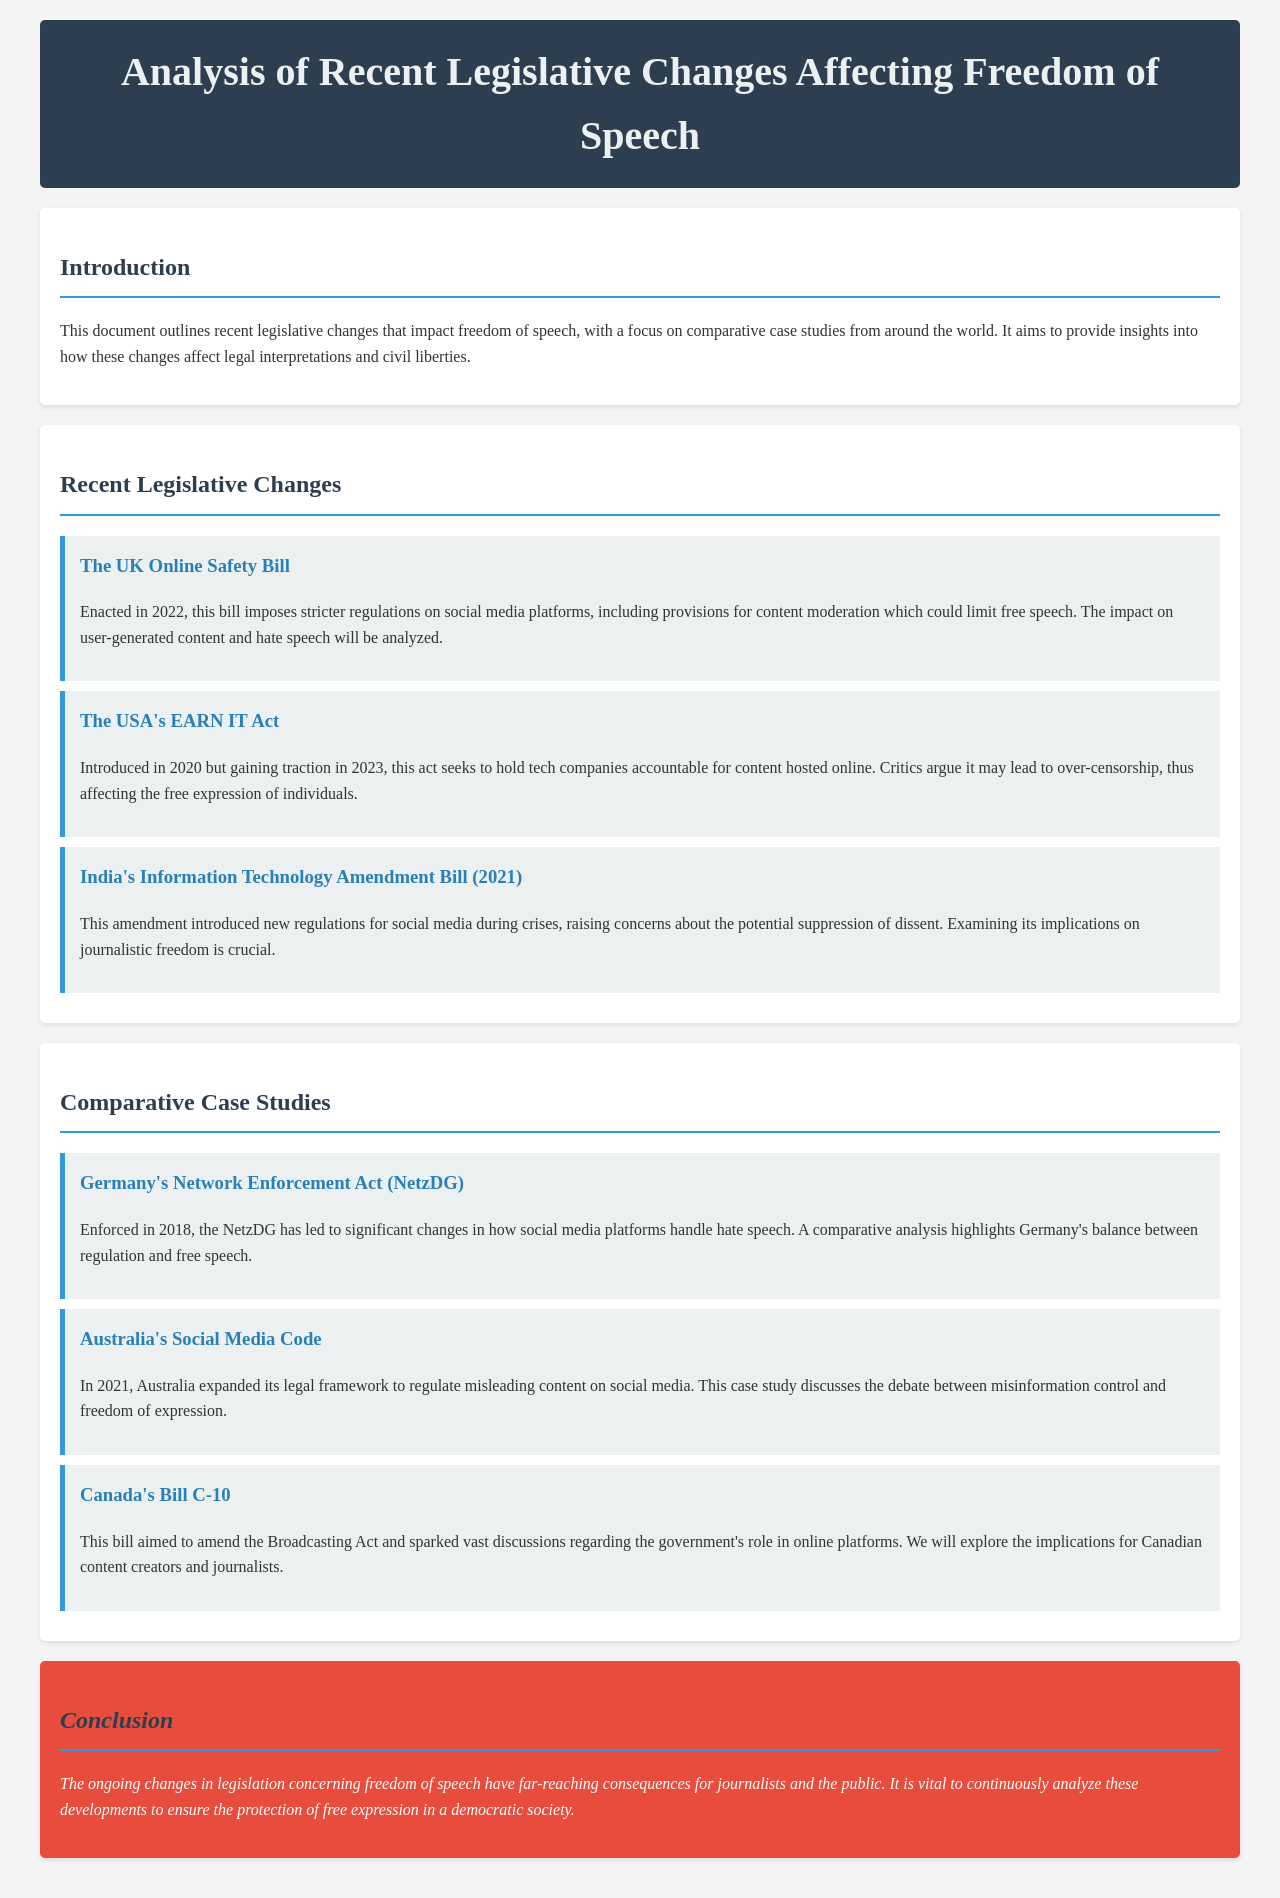what is the title of the document? The title is mentioned in the header and gives an overview of the content.
Answer: Analysis of Recent Legislative Changes Affecting Freedom of Speech when was the UK Online Safety Bill enacted? The document provides the specific year when this legislative change was enacted.
Answer: 2022 what is one of the main goals of the USA's EARN IT Act? The document outlines the act's intention toward tech companies and content regulation.
Answer: Hold tech companies accountable for content what concern does India's Information Technology Amendment Bill raise? The document indicates potential issues arising from the amendment regarding speech and freedom.
Answer: Potential suppression of dissent which country implemented the Network Enforcement Act in 2018? The case study section specifies the country and year of the regulation's enforcement.
Answer: Germany what is the subject of Australia's 2021 Social Media Code? This relates to the content regulation framework introduced by Australia in the specified year.
Answer: Regulate misleading content what does Canada’s Bill C-10 aim to amend? The document specifies the particular legislative framework that Bill C-10 seeks to revise.
Answer: Broadcasting Act what is emphasized in the conclusion regarding ongoing legislative changes? The conclusion discusses the impact and importance of analyzing changes in legislation.
Answer: Protection of free expression 